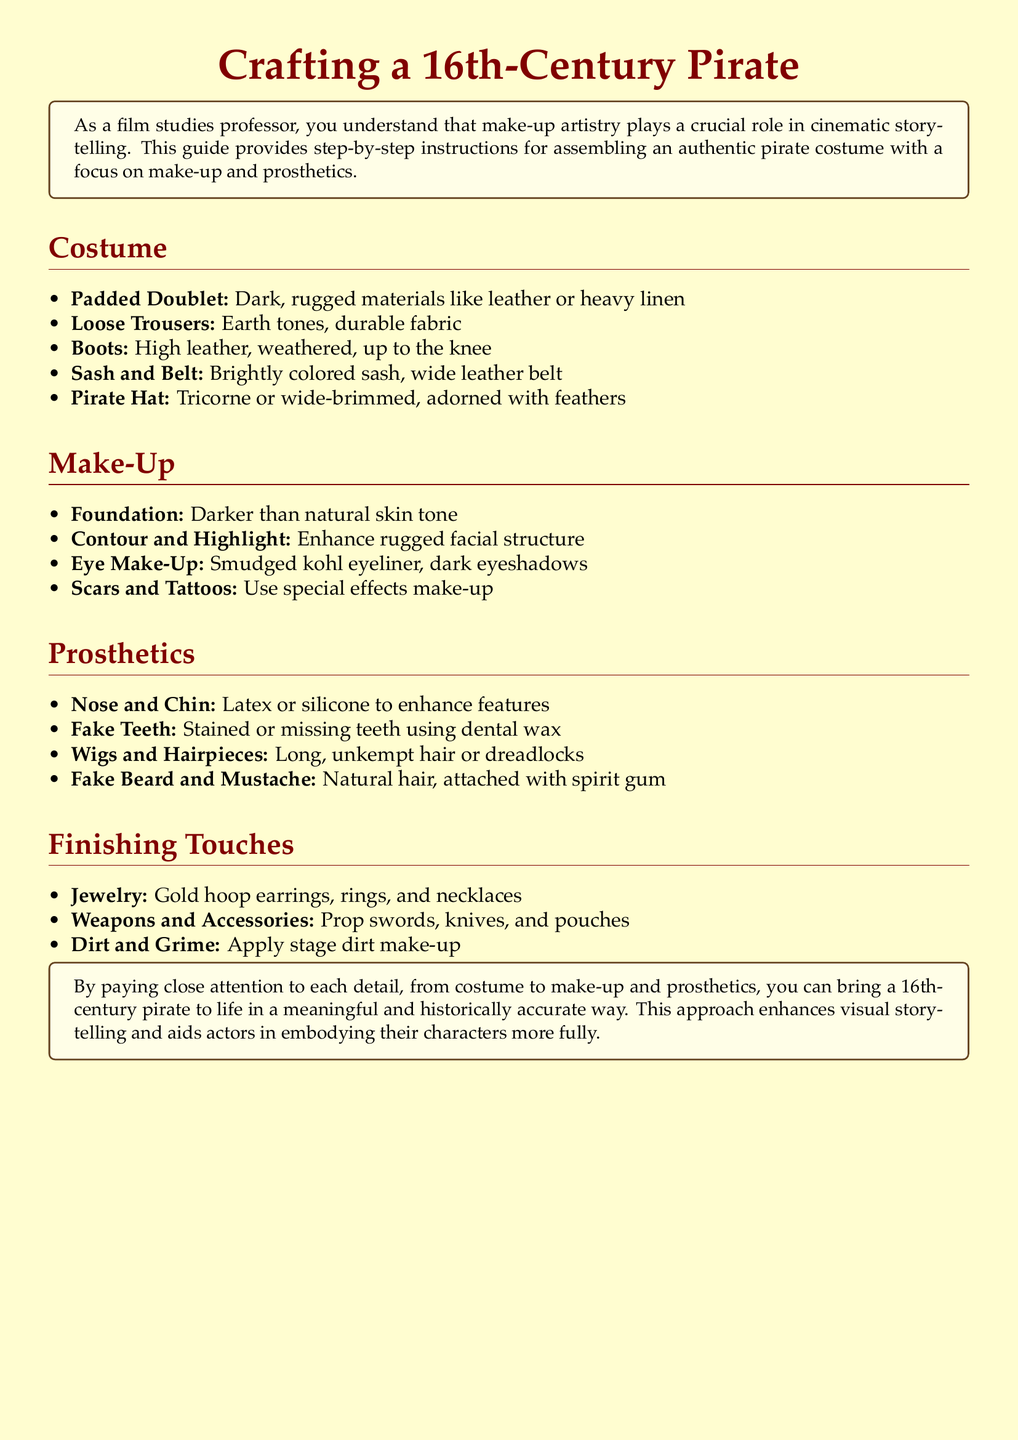What is the primary type of fabric for the padded doublet? The padded doublet should be made from dark, rugged materials like leather or heavy linen.
Answer: leather or heavy linen What color should the foundation make-up be? The foundation should be darker than the natural skin tone.
Answer: darker What type of wig is suggested for the pirate costume? The document suggests using long, unkempt hair or dreadlocks for the wig.
Answer: long, unkempt hair or dreadlocks How many types of accessories are listed under Finishing Touches? The section on Finishing Touches lists three types of accessories: jewelry, weapons and accessories, and dirt and grime.
Answer: three What are the materials suggested for fake teeth? The suggested materials for fake teeth are dental wax to create stained or missing teeth.
Answer: dental wax Why is attention to detail emphasized in the document? Attention to detail is emphasized to enhance visual storytelling and aid actors in embodying their characters more fully.
Answer: visual storytelling What is the name of the box color used for the tcolorbox? The tcolorbox uses the color piratecream for the background.
Answer: piratecream Which effect is suggested for creating scars? Special effects make-up is recommended for creating scars.
Answer: special effects make-up 